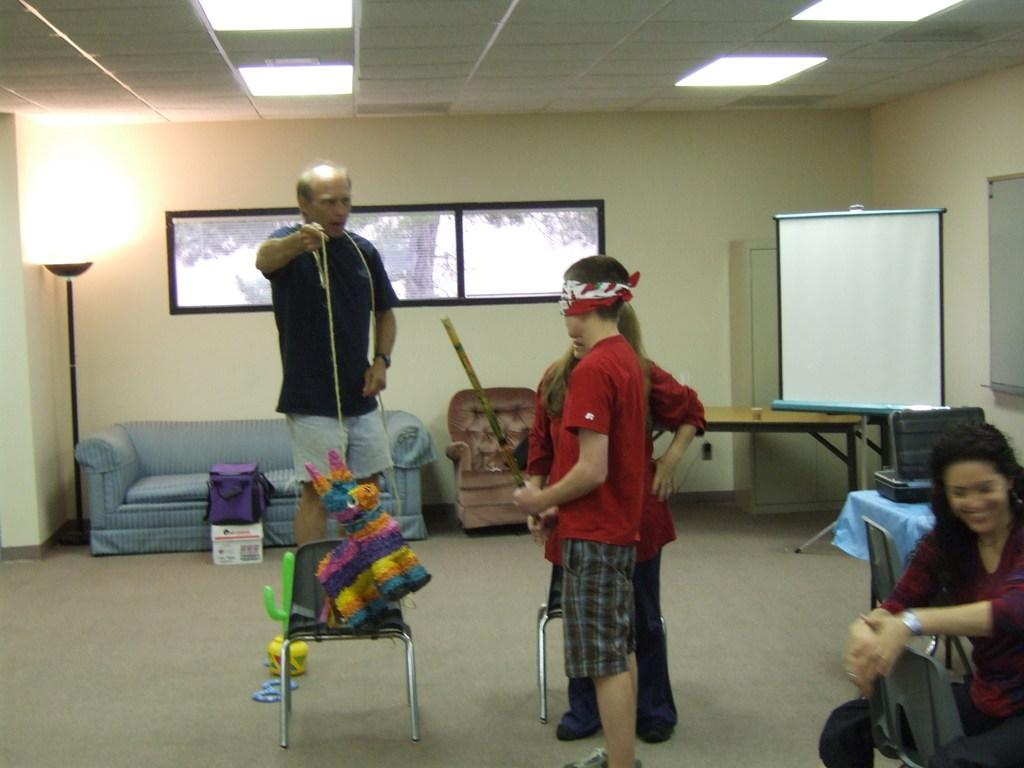How many people are present in the image? There are four people in the image. What type of furniture is visible in the image? There are two chairs and a sofa in the image. What is the source of light in the image? There is a light lamp in the image. What object might be used for writing or displaying information? There is a whiteboard in the image. What type of creature is sitting on the sofa in the image? There is no creature present in the image; it only features four people, furniture, and other objects. 